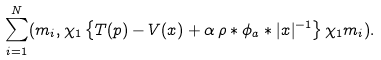Convert formula to latex. <formula><loc_0><loc_0><loc_500><loc_500>\sum _ { i = 1 } ^ { N } ( m _ { i } , \chi _ { 1 } \left \{ T ( p ) - V ( x ) + \alpha \, \rho * \phi _ { a } * | x | ^ { - 1 } \right \} \chi _ { 1 } m _ { i } ) .</formula> 